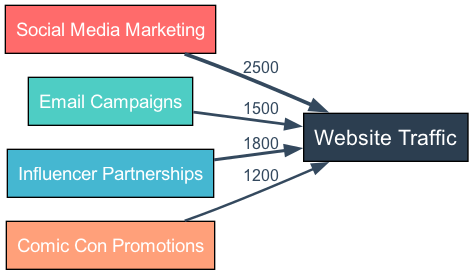What is the value associated with Social Media Marketing? The diagram indicates a link from Social Media Marketing to Website Traffic with a value of 2500, which can be directly read from the diagram.
Answer: 2500 What marketing strategy has the lowest contribution to website traffic? By examining the values of all marketing strategies, Comic Con Promotions has the lowest value of 1200. This can be established by comparing all values represented as links in the diagram.
Answer: Comic Con Promotions How many sources are present in the diagram? The sources in the diagram are listed and countable: Social Media Marketing, Email Campaigns, Influencer Partnerships, and Comic Con Promotions. Counting these gives a total of four sources.
Answer: 4 What is the total value of traffic contributed by all sources? To find the total value, I can sum the individual contributions: 2500 (Social Media) + 1500 (Email) + 1800 (Influencer) + 1200 (Comic Con) = 7000. The total can be calculated by adding the values of all the links.
Answer: 7000 What percentage of website traffic is contributed by Email Campaigns? Email Campaigns contribute 1500 out of a total of 7000. To calculate the percentage, I divide 1500 by 7000 and multiply by 100, resulting in approximately 21.43%. This requires both the contribution value and the total traffic value for accurate calculation.
Answer: 21.43% Which marketing strategy contributes more traffic: Influencer Partnerships or Email Campaigns? By comparing the values, Influencer Partnerships contributes 1800 while Email Campaigns contributes 1500. Thus, Influencer Partnerships has a higher value, and comparing the two visually or by reading the values can confirm this.
Answer: Influencer Partnerships How many edges are present in the diagram? Each link or connection from a source to the target counts as an edge. The diagram displays four links (one for each marketing strategy), resulting in a total of four edges. This is determined simply by counting the links visually represented.
Answer: 4 What is the relationship between Comic Con Promotions and Website Traffic? The relationship is direct; Comic Con Promotions is a source that leads to the target website traffic, with a specific contribution value of 1200. This is clearly indicated as a direct link from one to the other in the diagram.
Answer: Direct link 